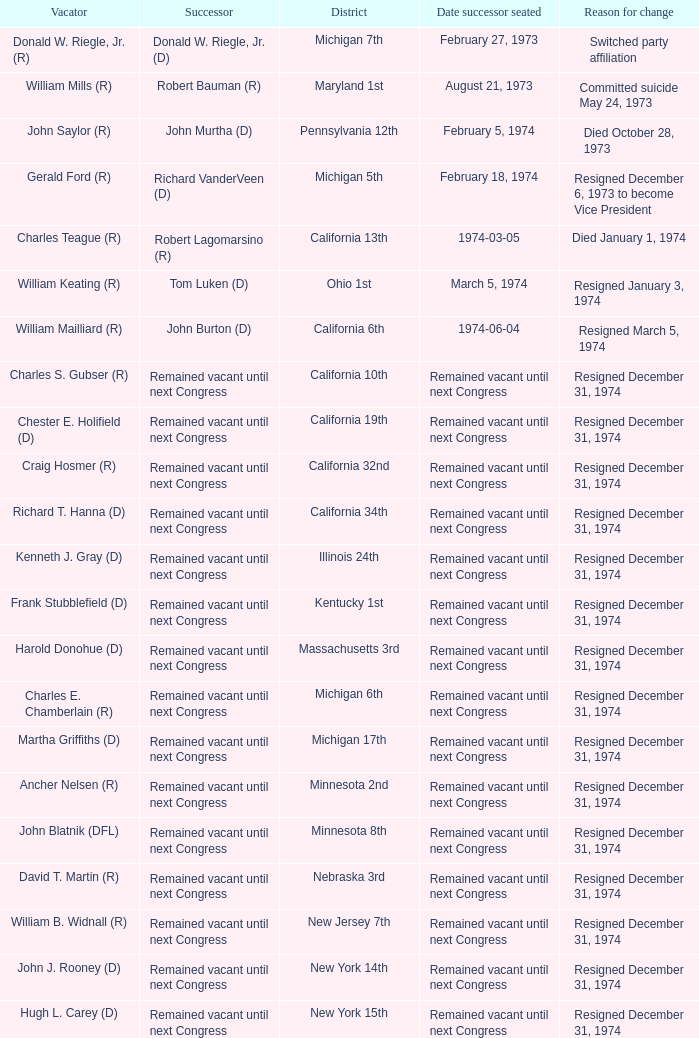When chester e. holifield (d) left the position, who succeeded him? Remained vacant until next Congress. 